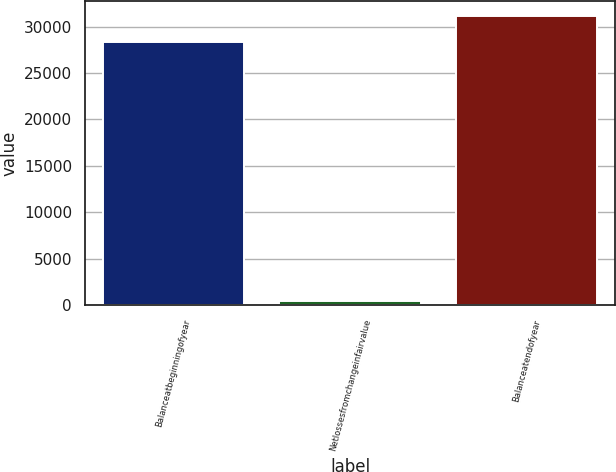Convert chart. <chart><loc_0><loc_0><loc_500><loc_500><bar_chart><fcel>Balanceatbeginningofyear<fcel>Netlossesfromchangeinfairvalue<fcel>Balanceatendofyear<nl><fcel>28360<fcel>410<fcel>31196<nl></chart> 